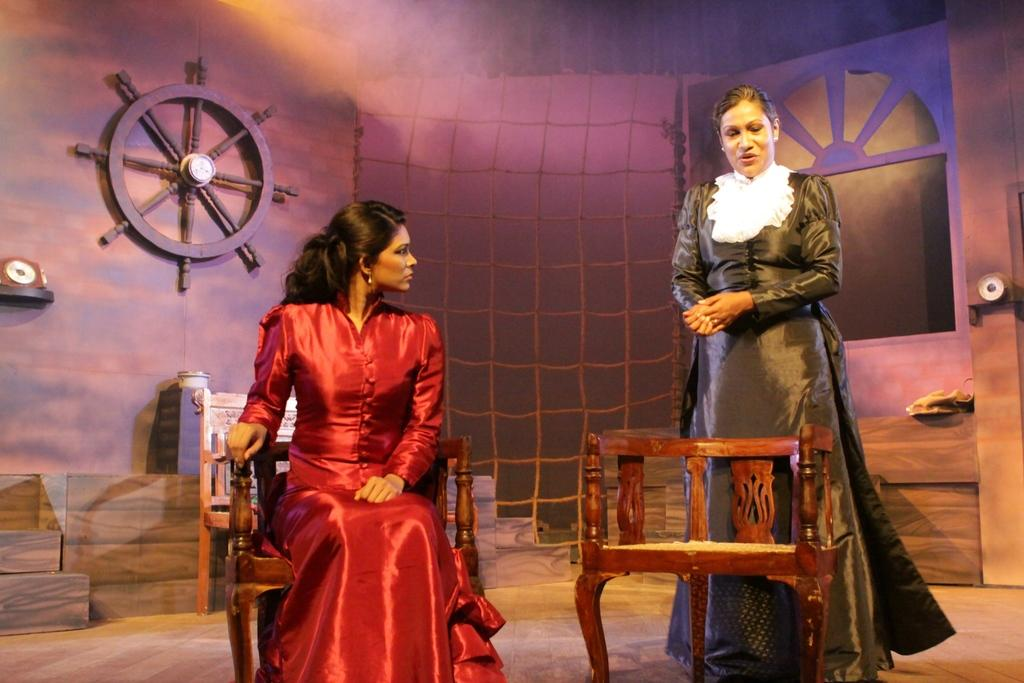What is the lady in the red dress wearing in the image? The lady in the red dress is wearing a red dress in the image. What is the lady in the red dress doing in the image? The lady in the red dress is sitting on a chair in the image. What is the lady in the black dress wearing in the image? The lady in the black dress is wearing a black dress in the image. What is the lady in the black dress doing in the image? The lady in the black dress is standing in the image. What can be seen in the background of the image? There is a wall and a net in the background of the image. What type of chalk is the lady in the red dress using to draw on the wall in the image? There is no chalk or drawing activity present in the image. How many turkeys can be seen in the image? There are no turkeys present in the image. 